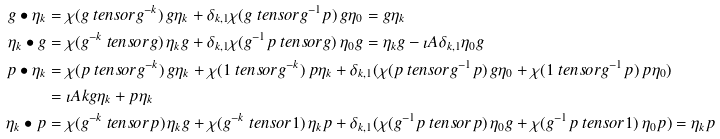<formula> <loc_0><loc_0><loc_500><loc_500>g \bullet \eta _ { k } & = \chi ( g \ t e n s o r g ^ { - k } ) \, g \eta _ { k } + \delta _ { k , 1 } \chi ( g \ t e n s o r g ^ { - 1 } p ) \, g \eta _ { 0 } = g \eta _ { k } \\ \eta _ { k } \bullet g & = \chi ( g ^ { - k } \ t e n s o r g ) \, \eta _ { k } g + \delta _ { k , 1 } \chi ( g ^ { - 1 } p \ t e n s o r g ) \, \eta _ { 0 } g = \eta _ { k } g - \imath A \delta _ { k , 1 } \eta _ { 0 } g \\ p \bullet \eta _ { k } & = \chi ( p \ t e n s o r g ^ { - k } ) \, g \eta _ { k } + \chi ( 1 \ t e n s o r g ^ { - k } ) \, p \eta _ { k } + \delta _ { k , 1 } ( \chi ( p \ t e n s o r g ^ { - 1 } p ) \, g \eta _ { 0 } + \chi ( 1 \ t e n s o r g ^ { - 1 } p ) \, p \eta _ { 0 } ) \\ & = \imath A k g \eta _ { k } + p \eta _ { k } \\ \eta _ { k } \bullet p & = \chi ( g ^ { - k } \ t e n s o r p ) \, \eta _ { k } g + \chi ( g ^ { - k } \ t e n s o r 1 ) \, \eta _ { k } p + \delta _ { k , 1 } ( \chi ( g ^ { - 1 } p \ t e n s o r p ) \, \eta _ { 0 } g + \chi ( g ^ { - 1 } p \ t e n s o r 1 ) \, \eta _ { 0 } p ) = \eta _ { k } p</formula> 